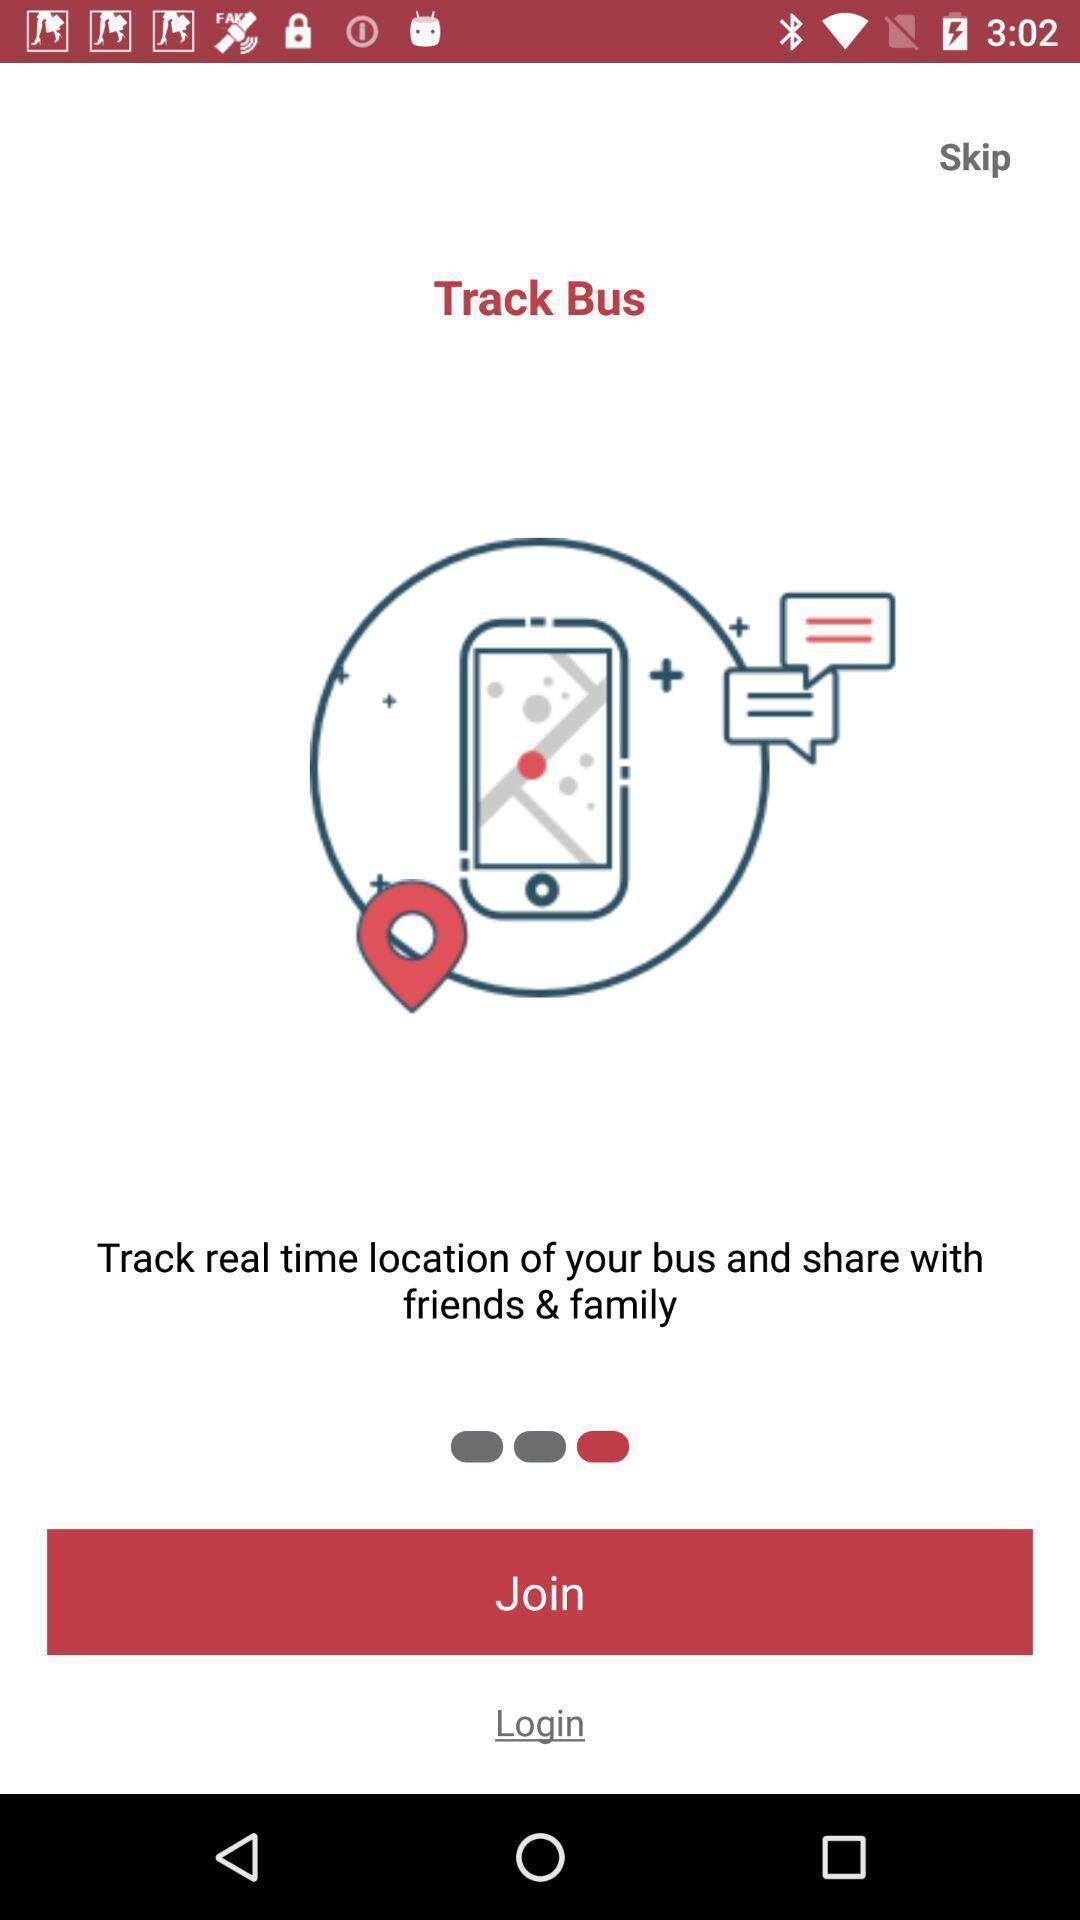Describe the content in this image. Welcome page of travel app. 